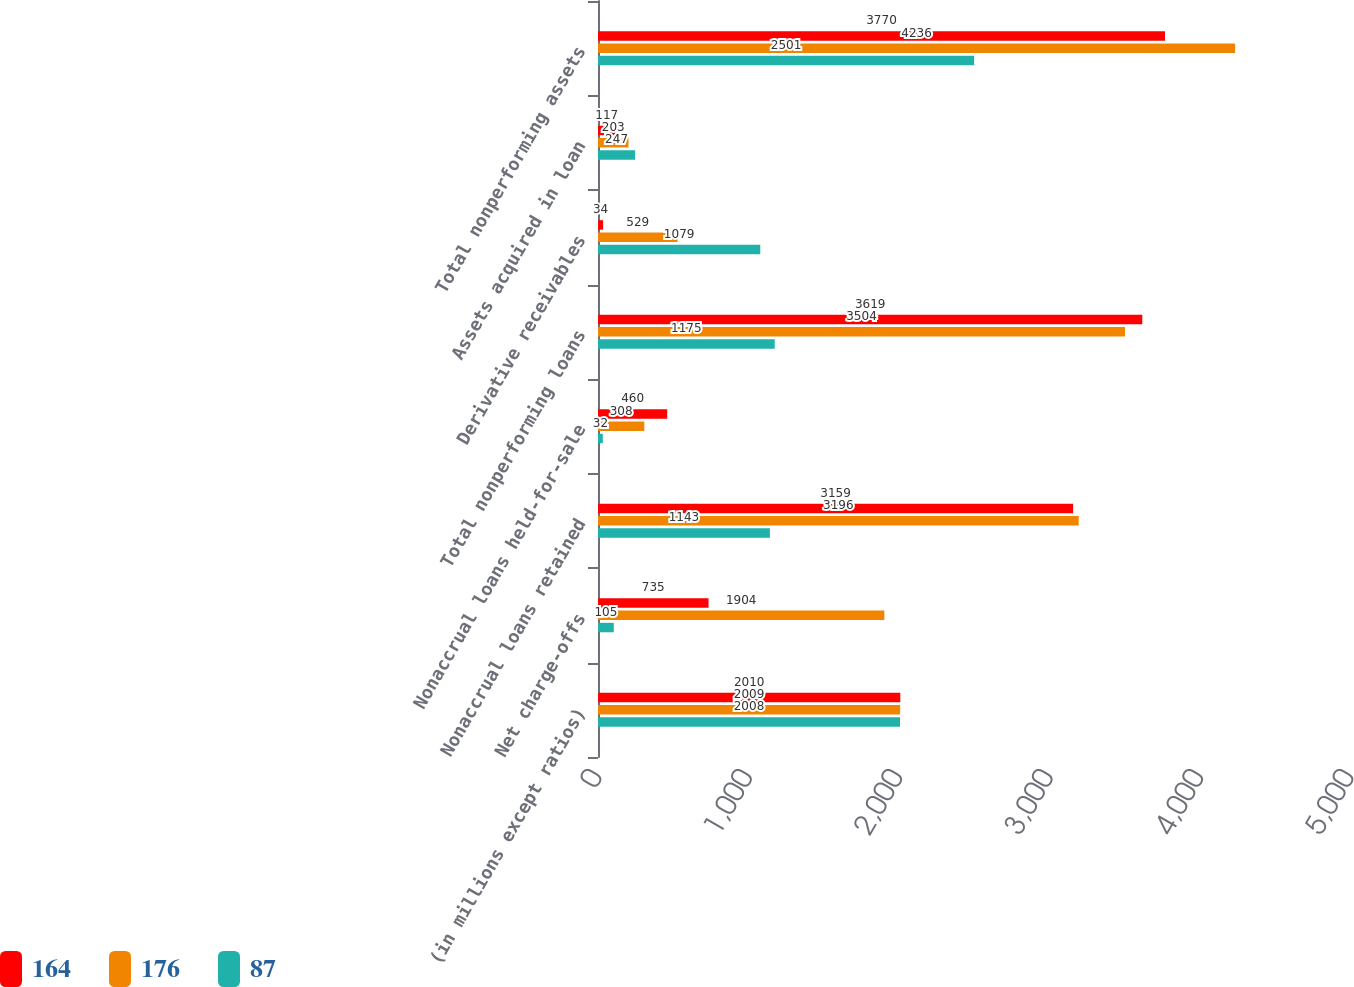Convert chart to OTSL. <chart><loc_0><loc_0><loc_500><loc_500><stacked_bar_chart><ecel><fcel>(in millions except ratios)<fcel>Net charge-offs<fcel>Nonaccrual loans retained<fcel>Nonaccrual loans held-for-sale<fcel>Total nonperforming loans<fcel>Derivative receivables<fcel>Assets acquired in loan<fcel>Total nonperforming assets<nl><fcel>164<fcel>2010<fcel>735<fcel>3159<fcel>460<fcel>3619<fcel>34<fcel>117<fcel>3770<nl><fcel>176<fcel>2009<fcel>1904<fcel>3196<fcel>308<fcel>3504<fcel>529<fcel>203<fcel>4236<nl><fcel>87<fcel>2008<fcel>105<fcel>1143<fcel>32<fcel>1175<fcel>1079<fcel>247<fcel>2501<nl></chart> 